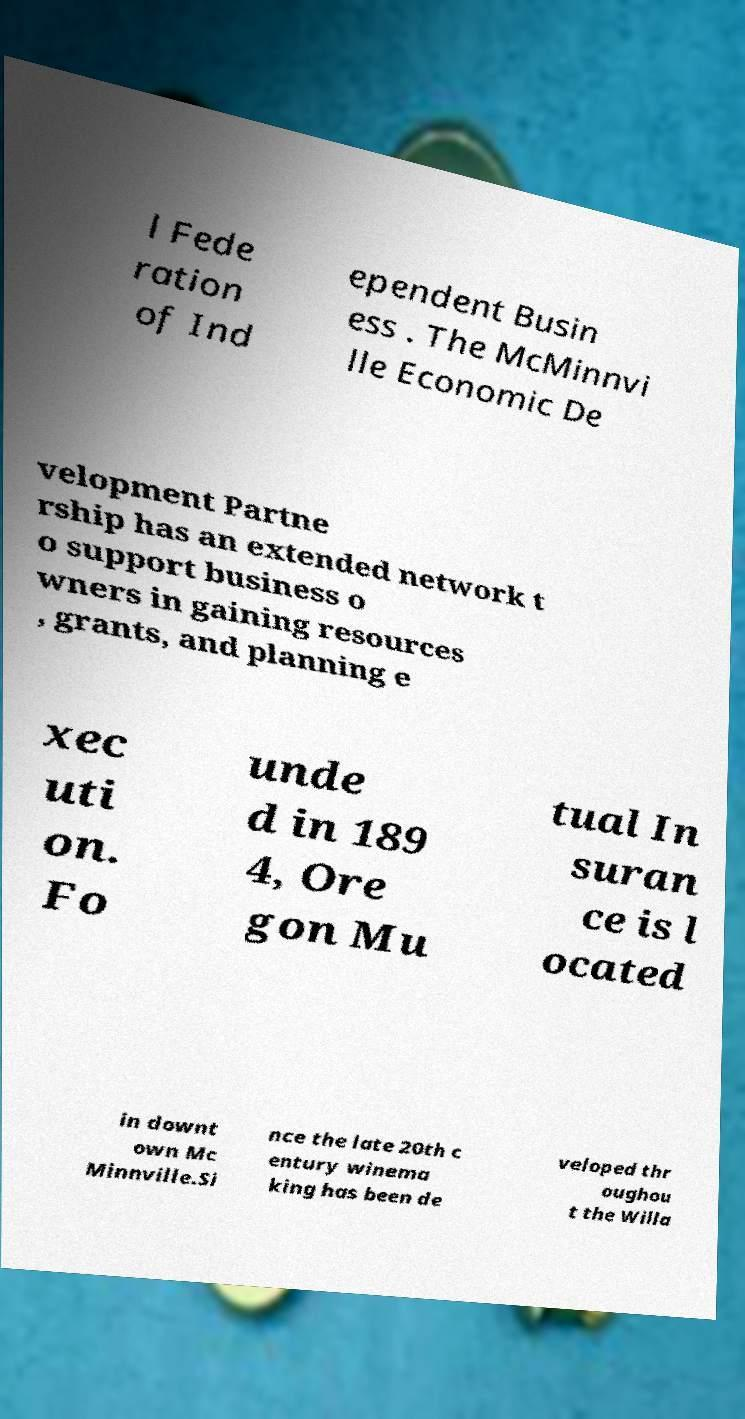Please read and relay the text visible in this image. What does it say? l Fede ration of Ind ependent Busin ess . The McMinnvi lle Economic De velopment Partne rship has an extended network t o support business o wners in gaining resources , grants, and planning e xec uti on. Fo unde d in 189 4, Ore gon Mu tual In suran ce is l ocated in downt own Mc Minnville.Si nce the late 20th c entury winema king has been de veloped thr oughou t the Willa 